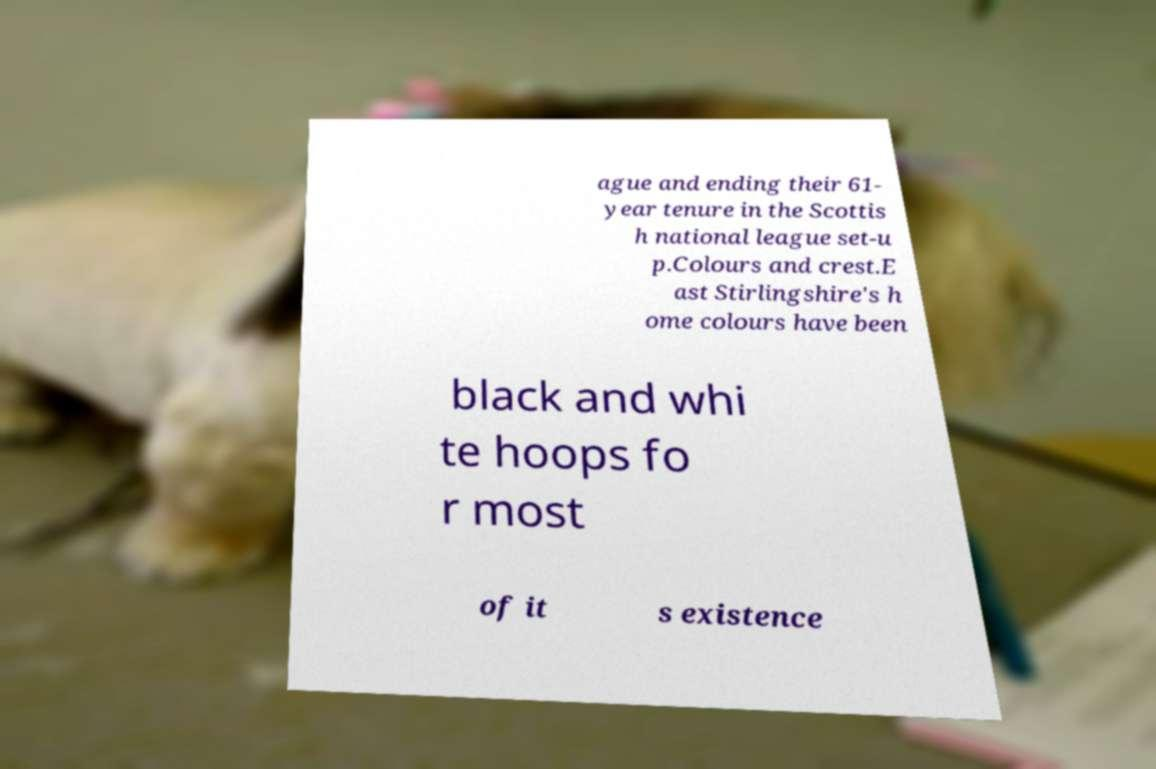Can you read and provide the text displayed in the image?This photo seems to have some interesting text. Can you extract and type it out for me? ague and ending their 61- year tenure in the Scottis h national league set-u p.Colours and crest.E ast Stirlingshire's h ome colours have been black and whi te hoops fo r most of it s existence 